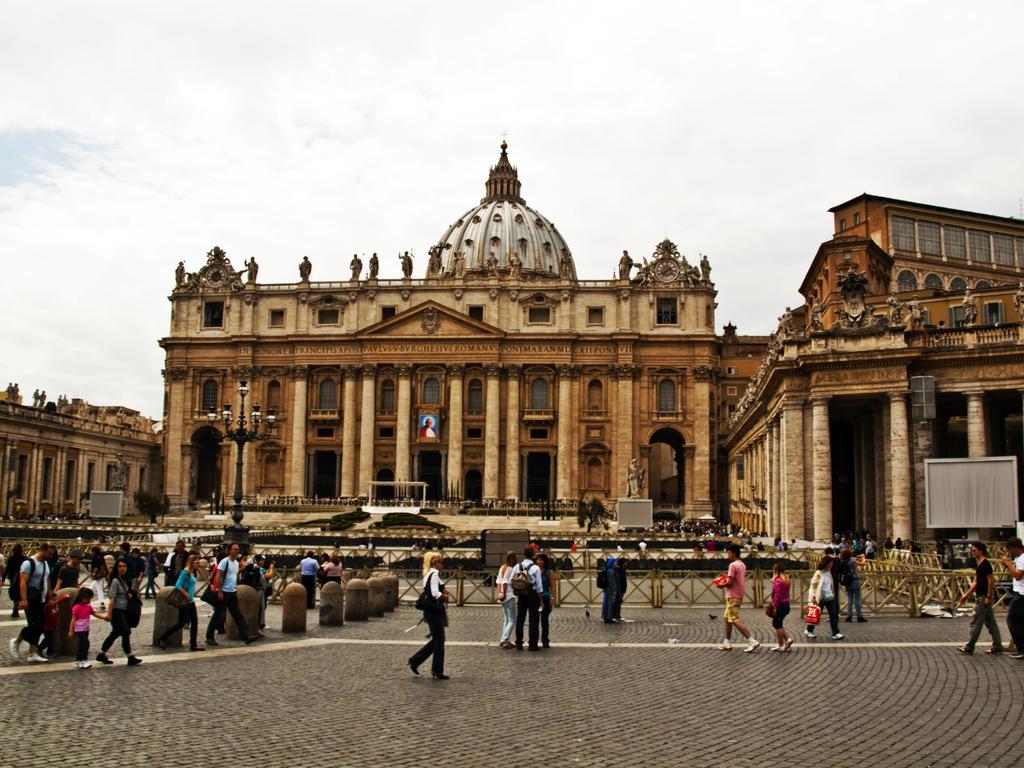Could you give a brief overview of what you see in this image? This is an outside view. At the bottom there are many people walking on the ground. In the background there are few buildings along with the pillars. At the top of the building there are few statues of persons. At the top of the image I can see the sky. 